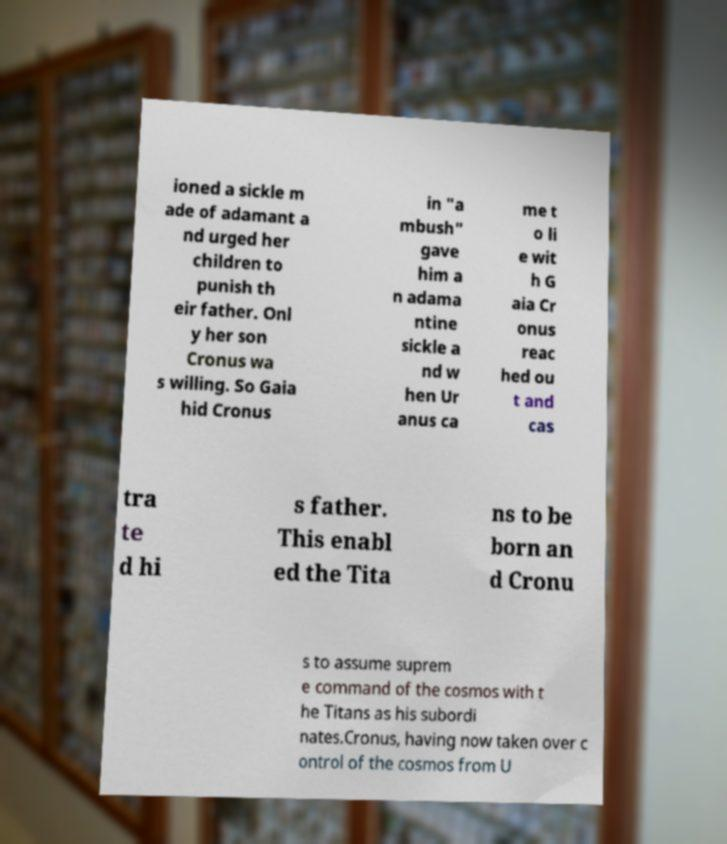Could you extract and type out the text from this image? ioned a sickle m ade of adamant a nd urged her children to punish th eir father. Onl y her son Cronus wa s willing. So Gaia hid Cronus in "a mbush" gave him a n adama ntine sickle a nd w hen Ur anus ca me t o li e wit h G aia Cr onus reac hed ou t and cas tra te d hi s father. This enabl ed the Tita ns to be born an d Cronu s to assume suprem e command of the cosmos with t he Titans as his subordi nates.Cronus, having now taken over c ontrol of the cosmos from U 